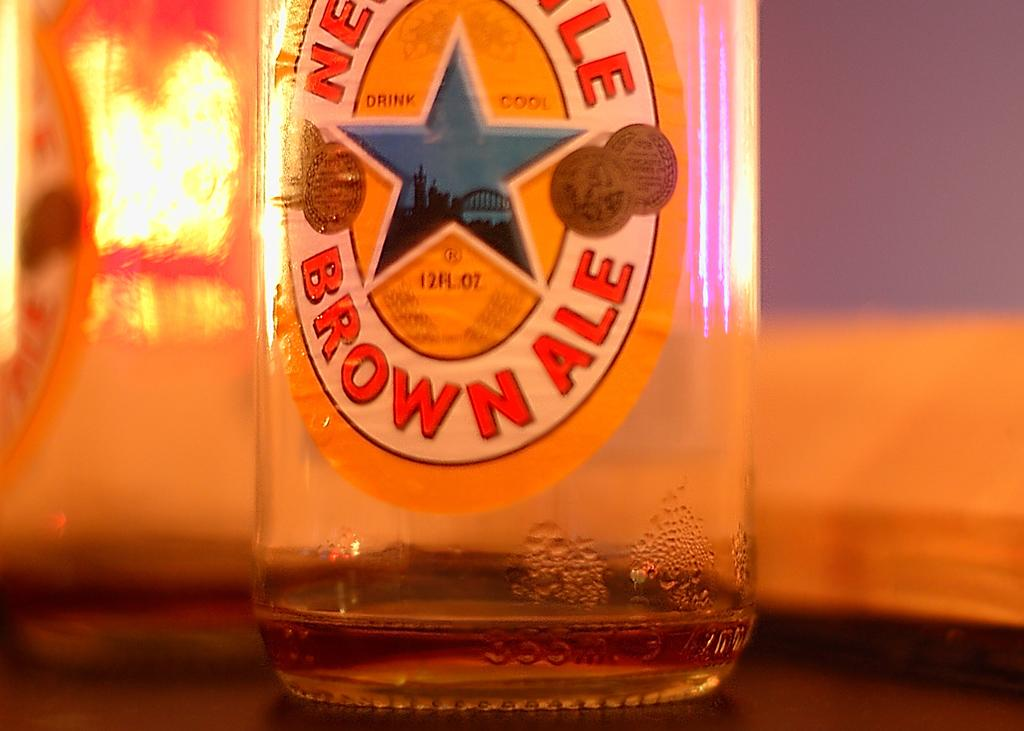<image>
Offer a succinct explanation of the picture presented. Empty bottle of brown ale on top of a surface. 